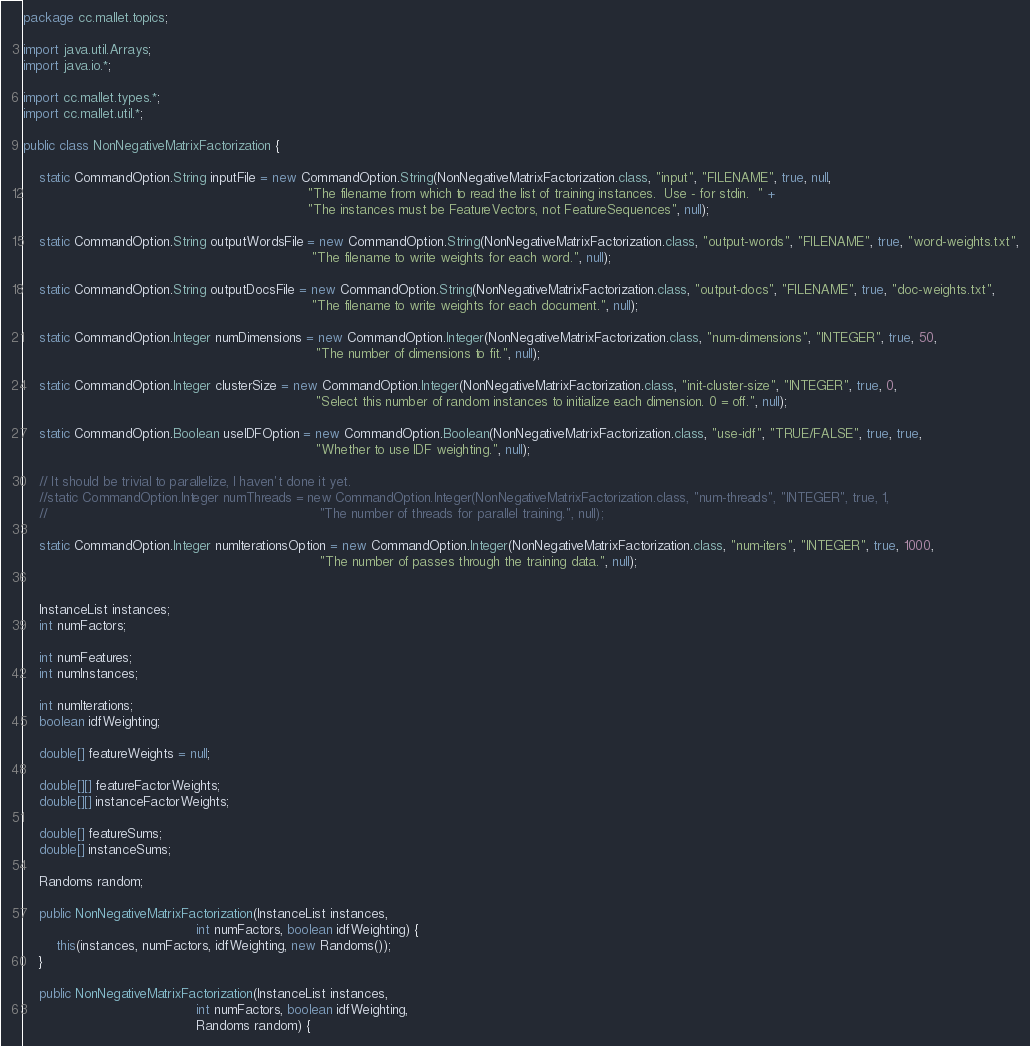<code> <loc_0><loc_0><loc_500><loc_500><_Java_>package cc.mallet.topics;

import java.util.Arrays;
import java.io.*;

import cc.mallet.types.*;
import cc.mallet.util.*;

public class NonNegativeMatrixFactorization {

	static CommandOption.String inputFile = new CommandOption.String(NonNegativeMatrixFactorization.class, "input", "FILENAME", true, null,
																	 "The filename from which to read the list of training instances.  Use - for stdin.  " +
																	 "The instances must be FeatureVectors, not FeatureSequences", null);
	
	static CommandOption.String outputWordsFile = new CommandOption.String(NonNegativeMatrixFactorization.class, "output-words", "FILENAME", true, "word-weights.txt",
																	  "The filename to write weights for each word.", null);
	
	static CommandOption.String outputDocsFile = new CommandOption.String(NonNegativeMatrixFactorization.class, "output-docs", "FILENAME", true, "doc-weights.txt",
																	  "The filename to write weights for each document.", null);
	
	static CommandOption.Integer numDimensions = new CommandOption.Integer(NonNegativeMatrixFactorization.class, "num-dimensions", "INTEGER", true, 50,
																	   "The number of dimensions to fit.", null);
	
	static CommandOption.Integer clusterSize = new CommandOption.Integer(NonNegativeMatrixFactorization.class, "init-cluster-size", "INTEGER", true, 0,
																	   "Select this number of random instances to initialize each dimension. 0 = off.", null);
	
	static CommandOption.Boolean useIDFOption = new CommandOption.Boolean(NonNegativeMatrixFactorization.class, "use-idf", "TRUE/FALSE", true, true,
																	   "Whether to use IDF weighting.", null);

	// It should be trivial to parallelize, I haven't done it yet.
	//static CommandOption.Integer numThreads = new CommandOption.Integer(NonNegativeMatrixFactorization.class, "num-threads", "INTEGER", true, 1,
	//																	"The number of threads for parallel training.", null);

	static CommandOption.Integer numIterationsOption = new CommandOption.Integer(NonNegativeMatrixFactorization.class, "num-iters", "INTEGER", true, 1000,
																		"The number of passes through the training data.", null);


	InstanceList instances;
	int numFactors;

	int numFeatures;
	int numInstances;
	
	int numIterations;
	boolean idfWeighting;

	double[] featureWeights = null;

	double[][] featureFactorWeights;
	double[][] instanceFactorWeights;

	double[] featureSums;
	double[] instanceSums;
	
	Randoms random;

	public NonNegativeMatrixFactorization(InstanceList instances,
                                          int numFactors, boolean idfWeighting) {
		this(instances, numFactors, idfWeighting, new Randoms());
	}

	public NonNegativeMatrixFactorization(InstanceList instances,
										  int numFactors, boolean idfWeighting,
										  Randoms random) {
</code> 